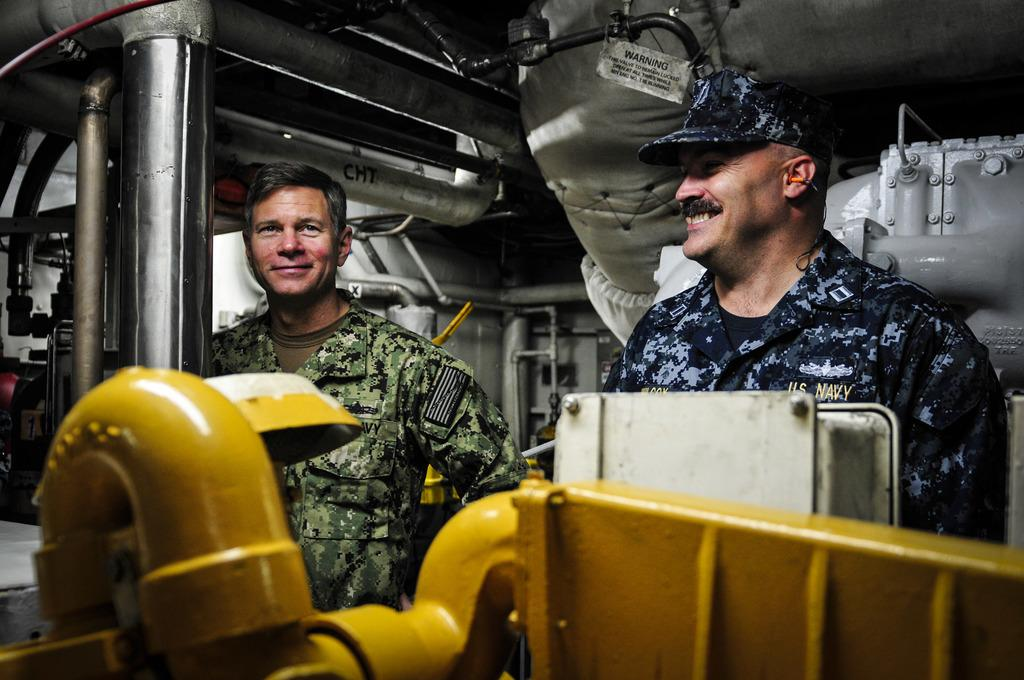How many people are in the image? There are two people in the image. What is the facial expression of the people in the image? The people are smiling. What type of objects can be seen in the image? There are metal pipes visible in the image. Are the two people in the image brothers? There is no information in the image to suggest that the two people are brothers. 